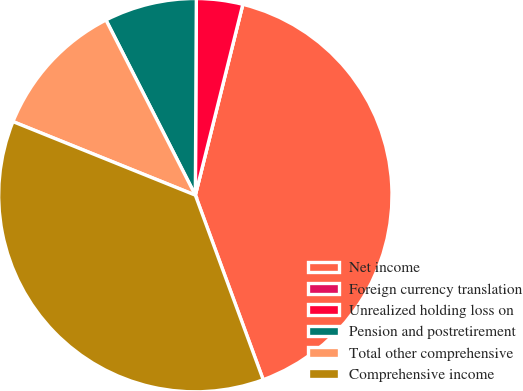Convert chart. <chart><loc_0><loc_0><loc_500><loc_500><pie_chart><fcel>Net income<fcel>Foreign currency translation<fcel>Unrealized holding loss on<fcel>Pension and postretirement<fcel>Total other comprehensive<fcel>Comprehensive income<nl><fcel>40.51%<fcel>0.0%<fcel>3.8%<fcel>7.59%<fcel>11.39%<fcel>36.71%<nl></chart> 